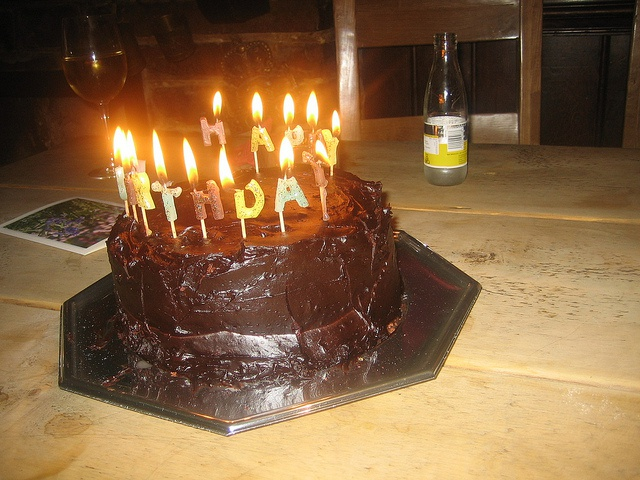Describe the objects in this image and their specific colors. I can see dining table in black, tan, and olive tones, cake in black, maroon, and brown tones, chair in black, maroon, and brown tones, wine glass in black, maroon, brown, and orange tones, and bottle in black, gray, lightgray, and maroon tones in this image. 